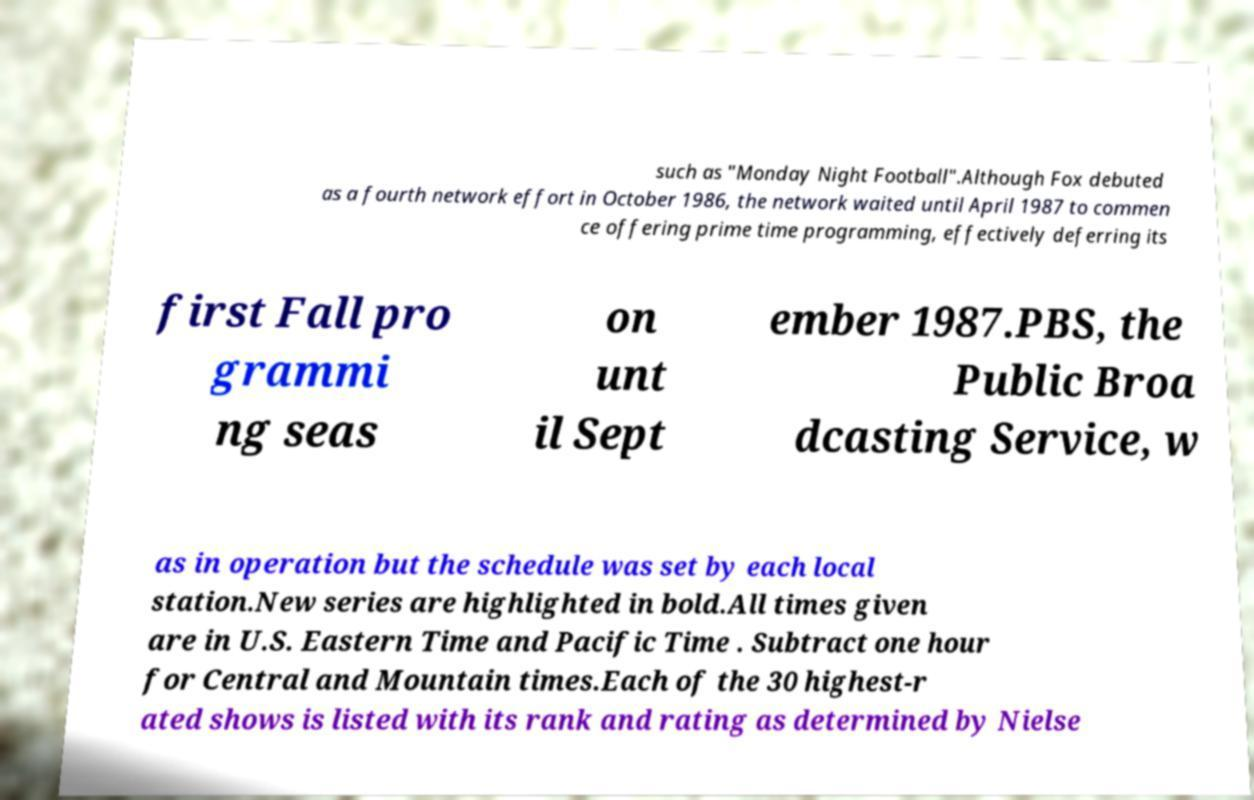Please read and relay the text visible in this image. What does it say? such as "Monday Night Football".Although Fox debuted as a fourth network effort in October 1986, the network waited until April 1987 to commen ce offering prime time programming, effectively deferring its first Fall pro grammi ng seas on unt il Sept ember 1987.PBS, the Public Broa dcasting Service, w as in operation but the schedule was set by each local station.New series are highlighted in bold.All times given are in U.S. Eastern Time and Pacific Time . Subtract one hour for Central and Mountain times.Each of the 30 highest-r ated shows is listed with its rank and rating as determined by Nielse 